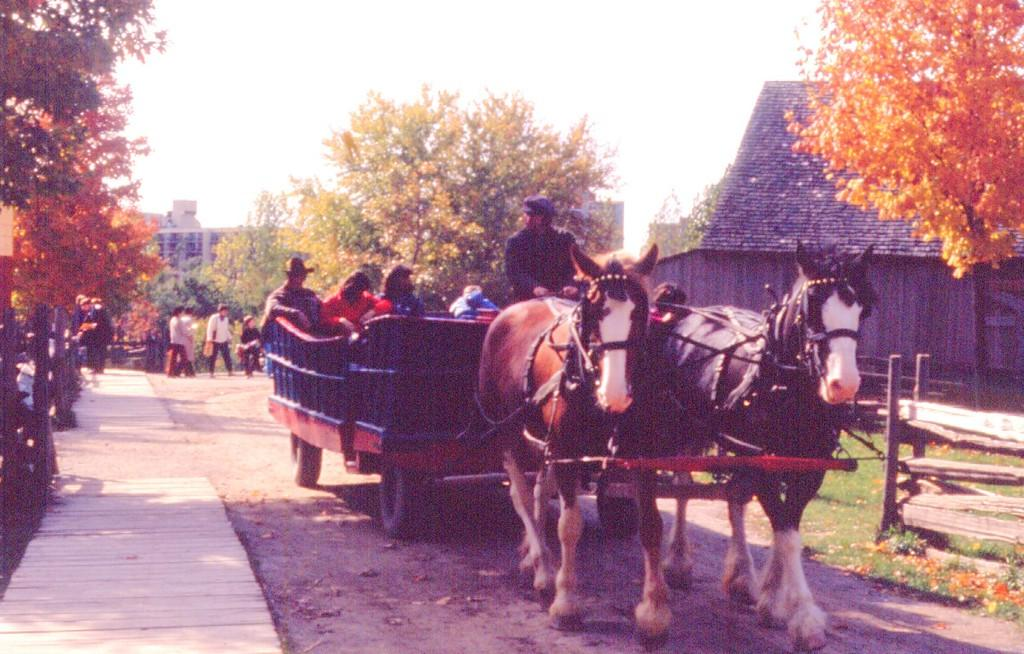What are the people in the image riding? The people in the image are riding a horse cart. What can be seen in the background of the image? There are trees, buildings, people, poles, and a fence visible in the background of the image. What is at the bottom of the image? The ground is visible at the bottom of the image. What type of bone is being used as a decoration on the horse cart? There is no bone present on the horse cart in the image. Can you tell me how many tickets are visible in the image? There are no tickets visible in the image. 